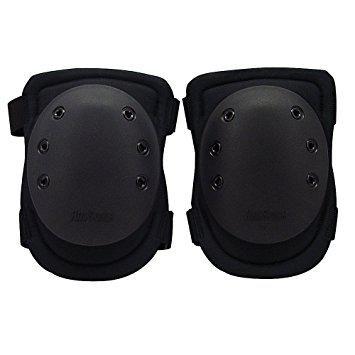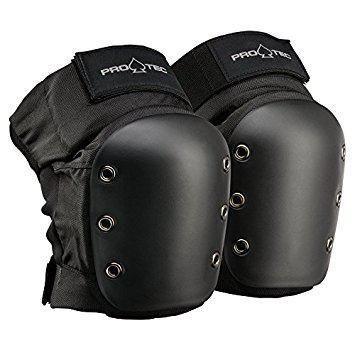The first image is the image on the left, the second image is the image on the right. Considering the images on both sides, is "There are three greyish colored pads." valid? Answer yes or no. No. The first image is the image on the left, the second image is the image on the right. Given the left and right images, does the statement "The left image contains one kneepad, while the right image contains a pair." hold true? Answer yes or no. No. 